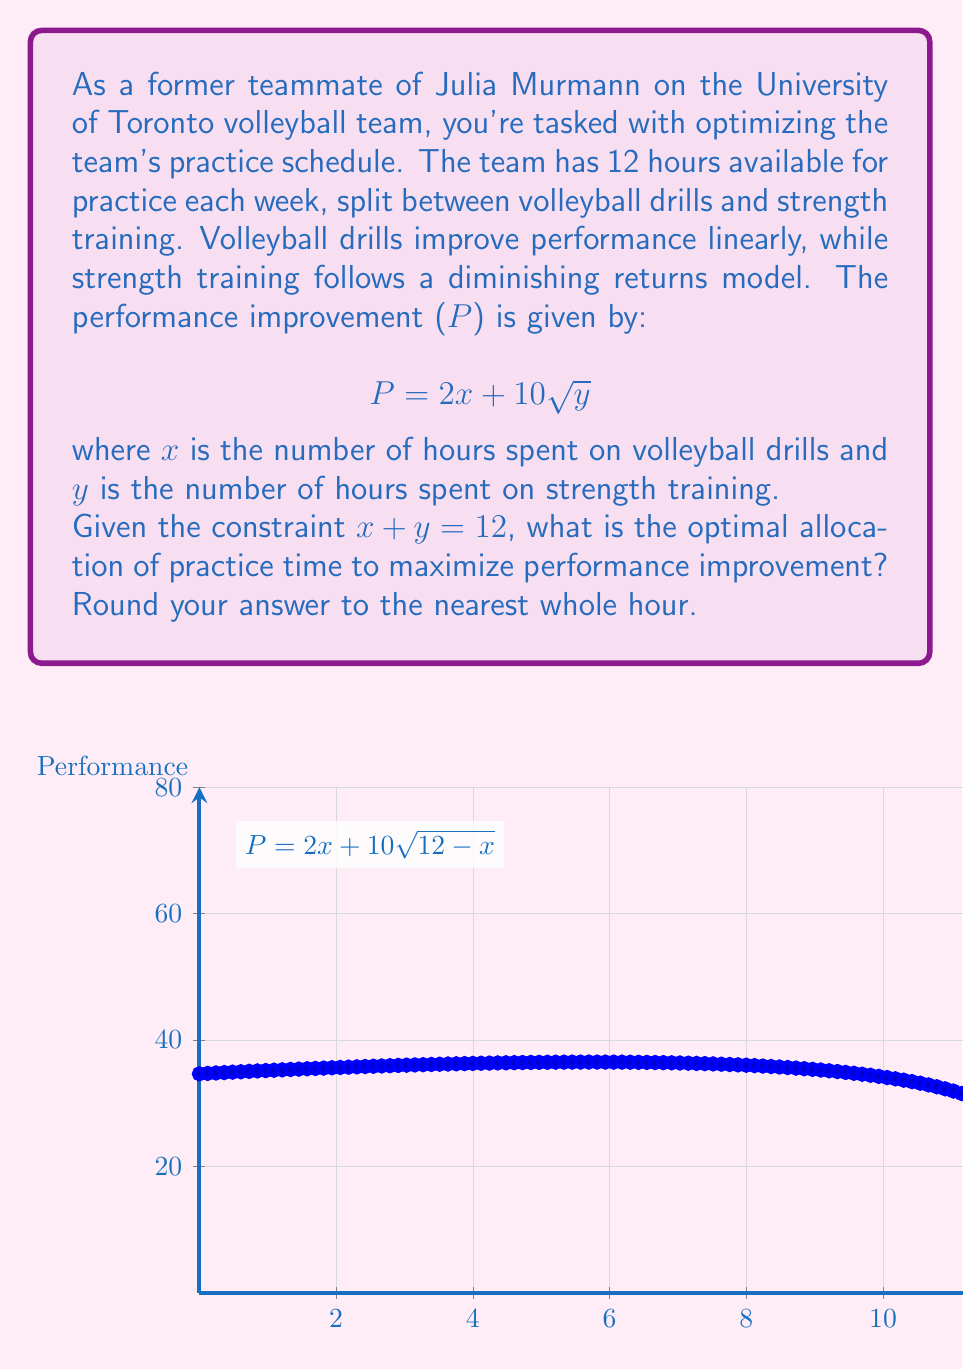Can you answer this question? To solve this optimization problem, we'll use calculus:

1) First, substitute $y = 12 - x$ into the performance function:
   $$P = 2x + 10\sqrt{12-x}$$

2) To find the maximum, differentiate P with respect to x and set it to zero:
   $$\frac{dP}{dx} = 2 - \frac{10}{2\sqrt{12-x}} = 0$$

3) Solve this equation:
   $$2 = \frac{5}{\sqrt{12-x}}$$
   $$4 = \frac{25}{12-x}$$
   $$4(12-x) = 25$$
   $$48 - 4x = 25$$
   $$23 = 4x$$
   $$x = 5.75$$

4) Since $x + y = 12$, $y = 12 - 5.75 = 6.25$

5) Rounding to the nearest whole hour:
   $x ≈ 6$ hours (volleyball drills)
   $y ≈ 6$ hours (strength training)

6) To verify this is a maximum, we could check the second derivative is negative at this point.
Answer: 6 hours volleyball drills, 6 hours strength training 